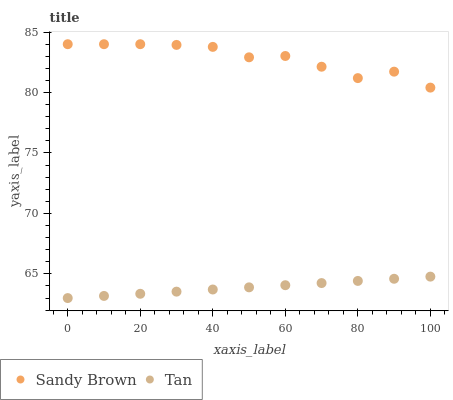Does Tan have the minimum area under the curve?
Answer yes or no. Yes. Does Sandy Brown have the maximum area under the curve?
Answer yes or no. Yes. Does Sandy Brown have the minimum area under the curve?
Answer yes or no. No. Is Tan the smoothest?
Answer yes or no. Yes. Is Sandy Brown the roughest?
Answer yes or no. Yes. Is Sandy Brown the smoothest?
Answer yes or no. No. Does Tan have the lowest value?
Answer yes or no. Yes. Does Sandy Brown have the lowest value?
Answer yes or no. No. Does Sandy Brown have the highest value?
Answer yes or no. Yes. Is Tan less than Sandy Brown?
Answer yes or no. Yes. Is Sandy Brown greater than Tan?
Answer yes or no. Yes. Does Tan intersect Sandy Brown?
Answer yes or no. No. 